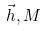<formula> <loc_0><loc_0><loc_500><loc_500>\vec { h } , M</formula> 